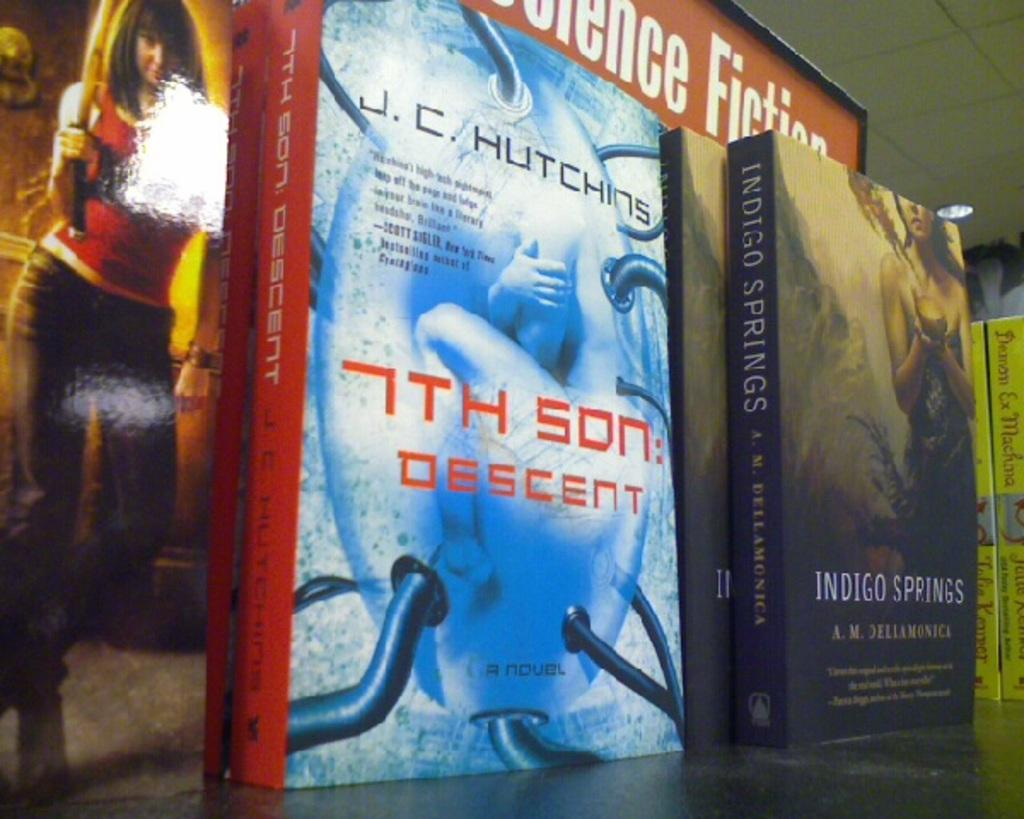<image>
Present a compact description of the photo's key features. A Science Fiction book display with books called 7th Son: Descent and Indigo Springs 